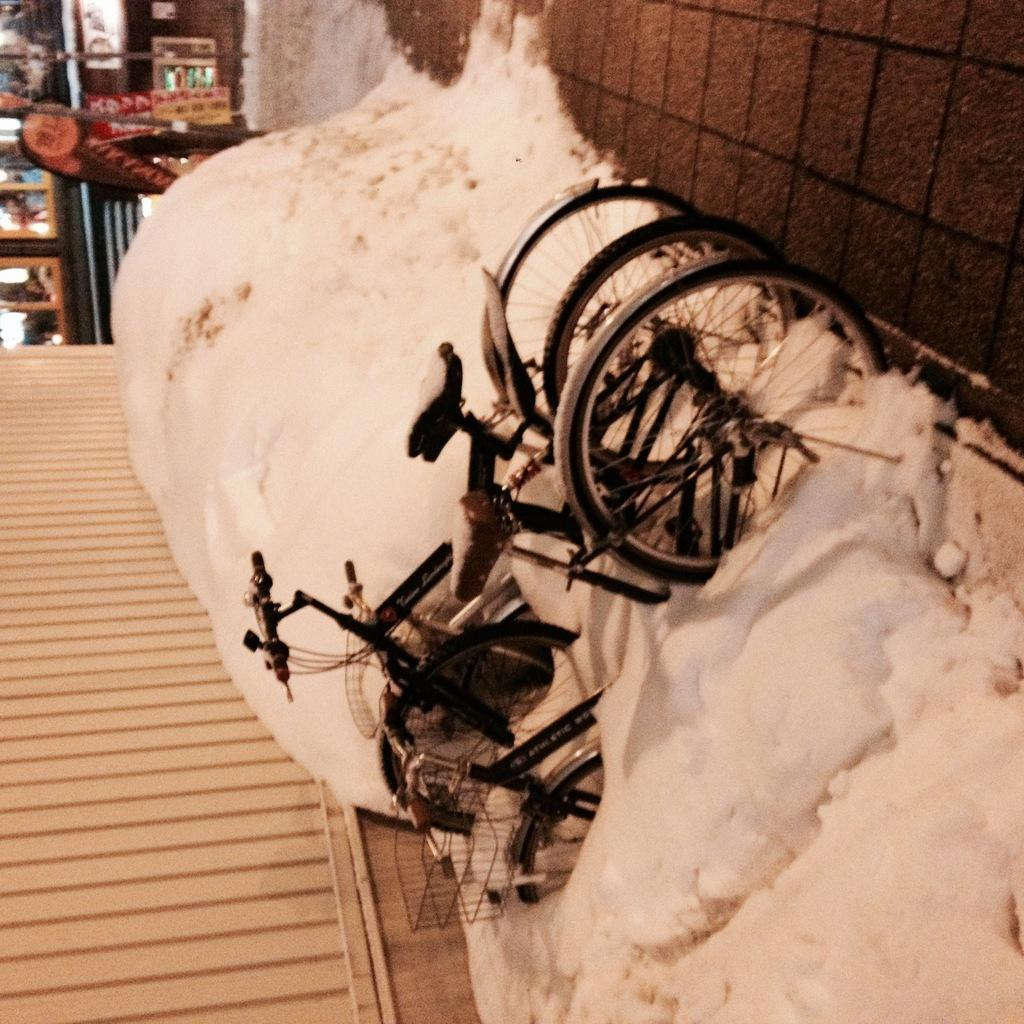What type of vehicles are in the image? There are bicycles in the image. What is the condition of the ground in the image? There is snow on the ground in the image. What type of establishments can be seen in the image? There are stores visible in the image. What is a prominent feature in the image? There is a wall in the image. What type of decorations are in the image? There are posters in the image. What type of plant is growing on the basketball court in the image? There is no basketball court or plant present in the image. 